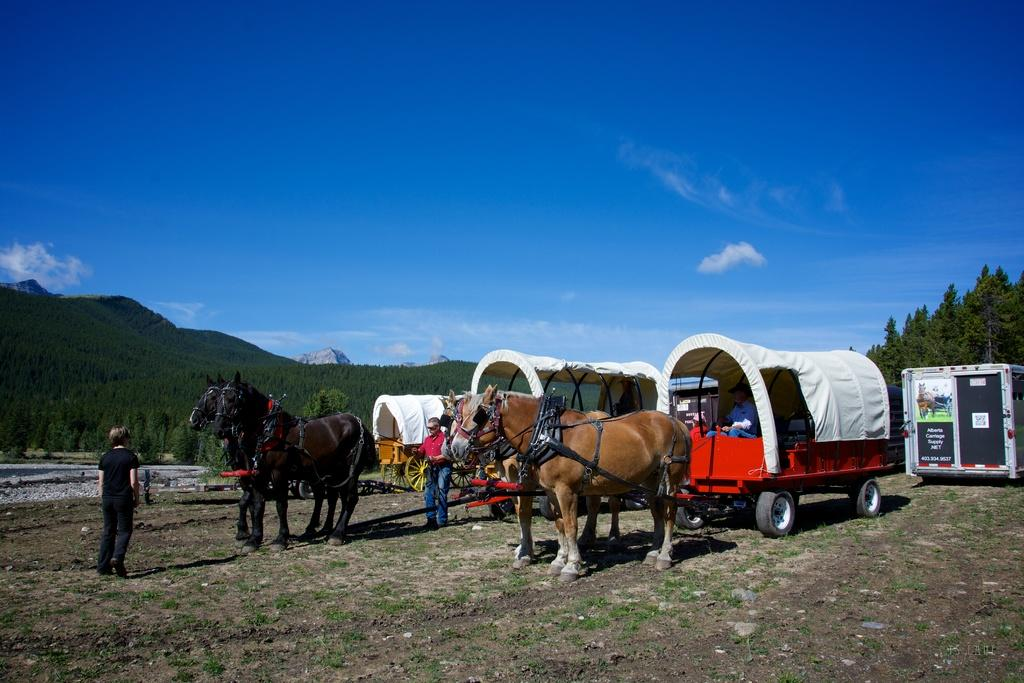What animals are present in the image? There are horses in the image. What other subjects are present in the image besides the horses? There are people and carts in the image. What can be seen in the background of the image? There are trees, clouds, and the sky visible in the background of the image. Is there any text or writing present in the image? Yes, there is text or writing present in the image. What type of hose can be seen in the image? There is no hose present in the image. How many snakes are slithering around the horses in the image? There are no snakes present in the image; it features horses, people, and carts. What type of drink is being consumed by the people in the image? There is no drink visible in the image; it only shows horses, people, carts, and the background elements. 